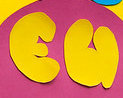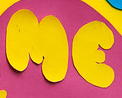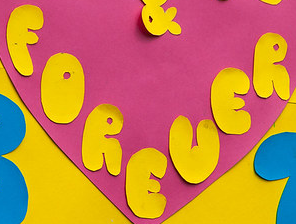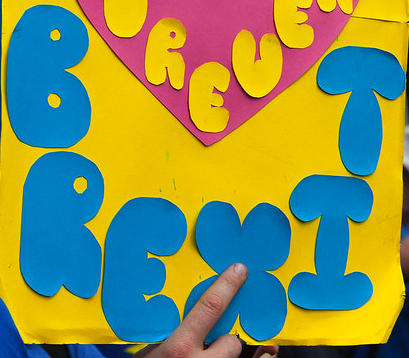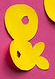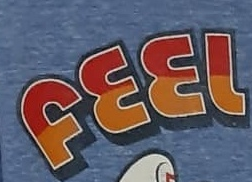What words can you see in these images in sequence, separated by a semicolon? EU; ME; FOREUER; BREXIT; &; FEEL 